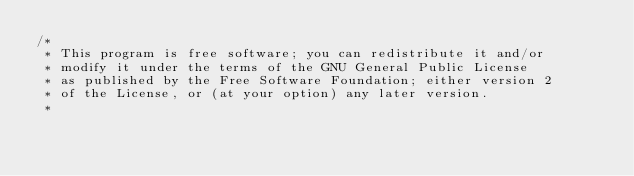Convert code to text. <code><loc_0><loc_0><loc_500><loc_500><_C_>/*
 * This program is free software; you can redistribute it and/or
 * modify it under the terms of the GNU General Public License
 * as published by the Free Software Foundation; either version 2
 * of the License, or (at your option) any later version.
 *</code> 